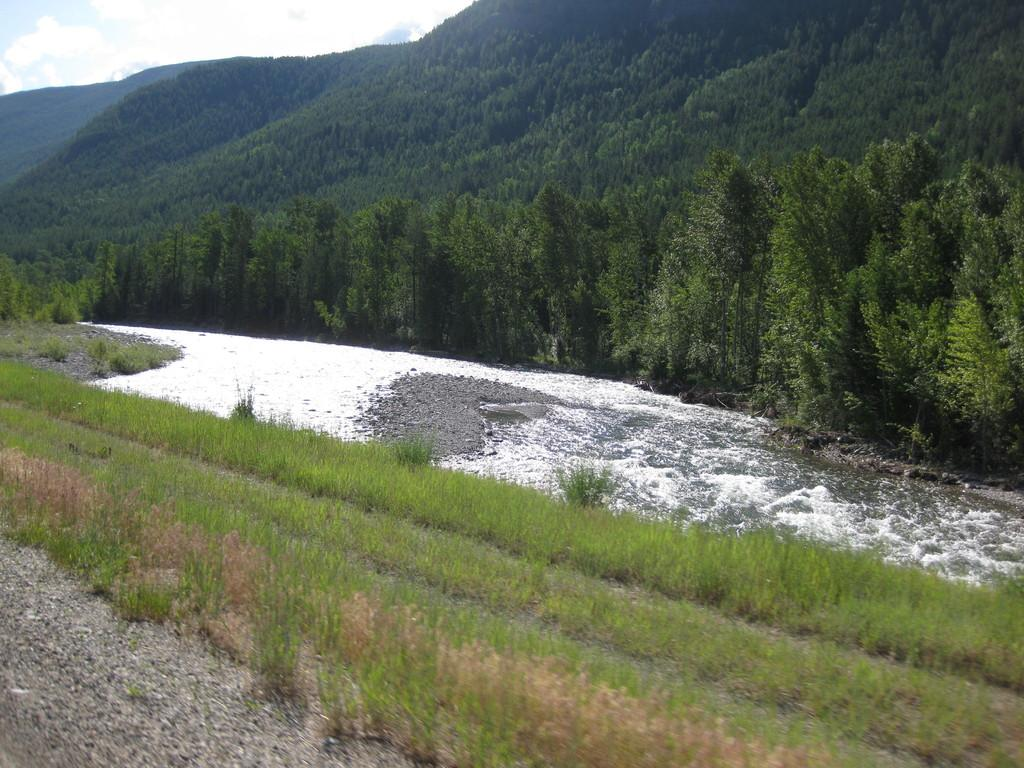What can be seen in the background of the image? The sky is visible in the background of the image. What type of vegetation is present in the image? There are trees and plants in the image. What is the thicket in the image made of? The thicket in the image is made of plants. Is there any water visible in the image? Yes, there is water in the image. Can you see a girl using a hose to water the plants in the image? There is no girl or hose present in the image. What type of air is visible in the image? There is no specific type of air visible in the image; it is simply the sky in the background. 